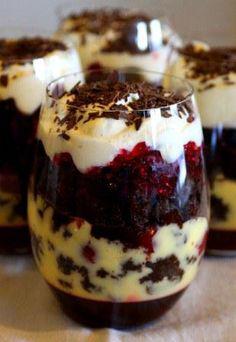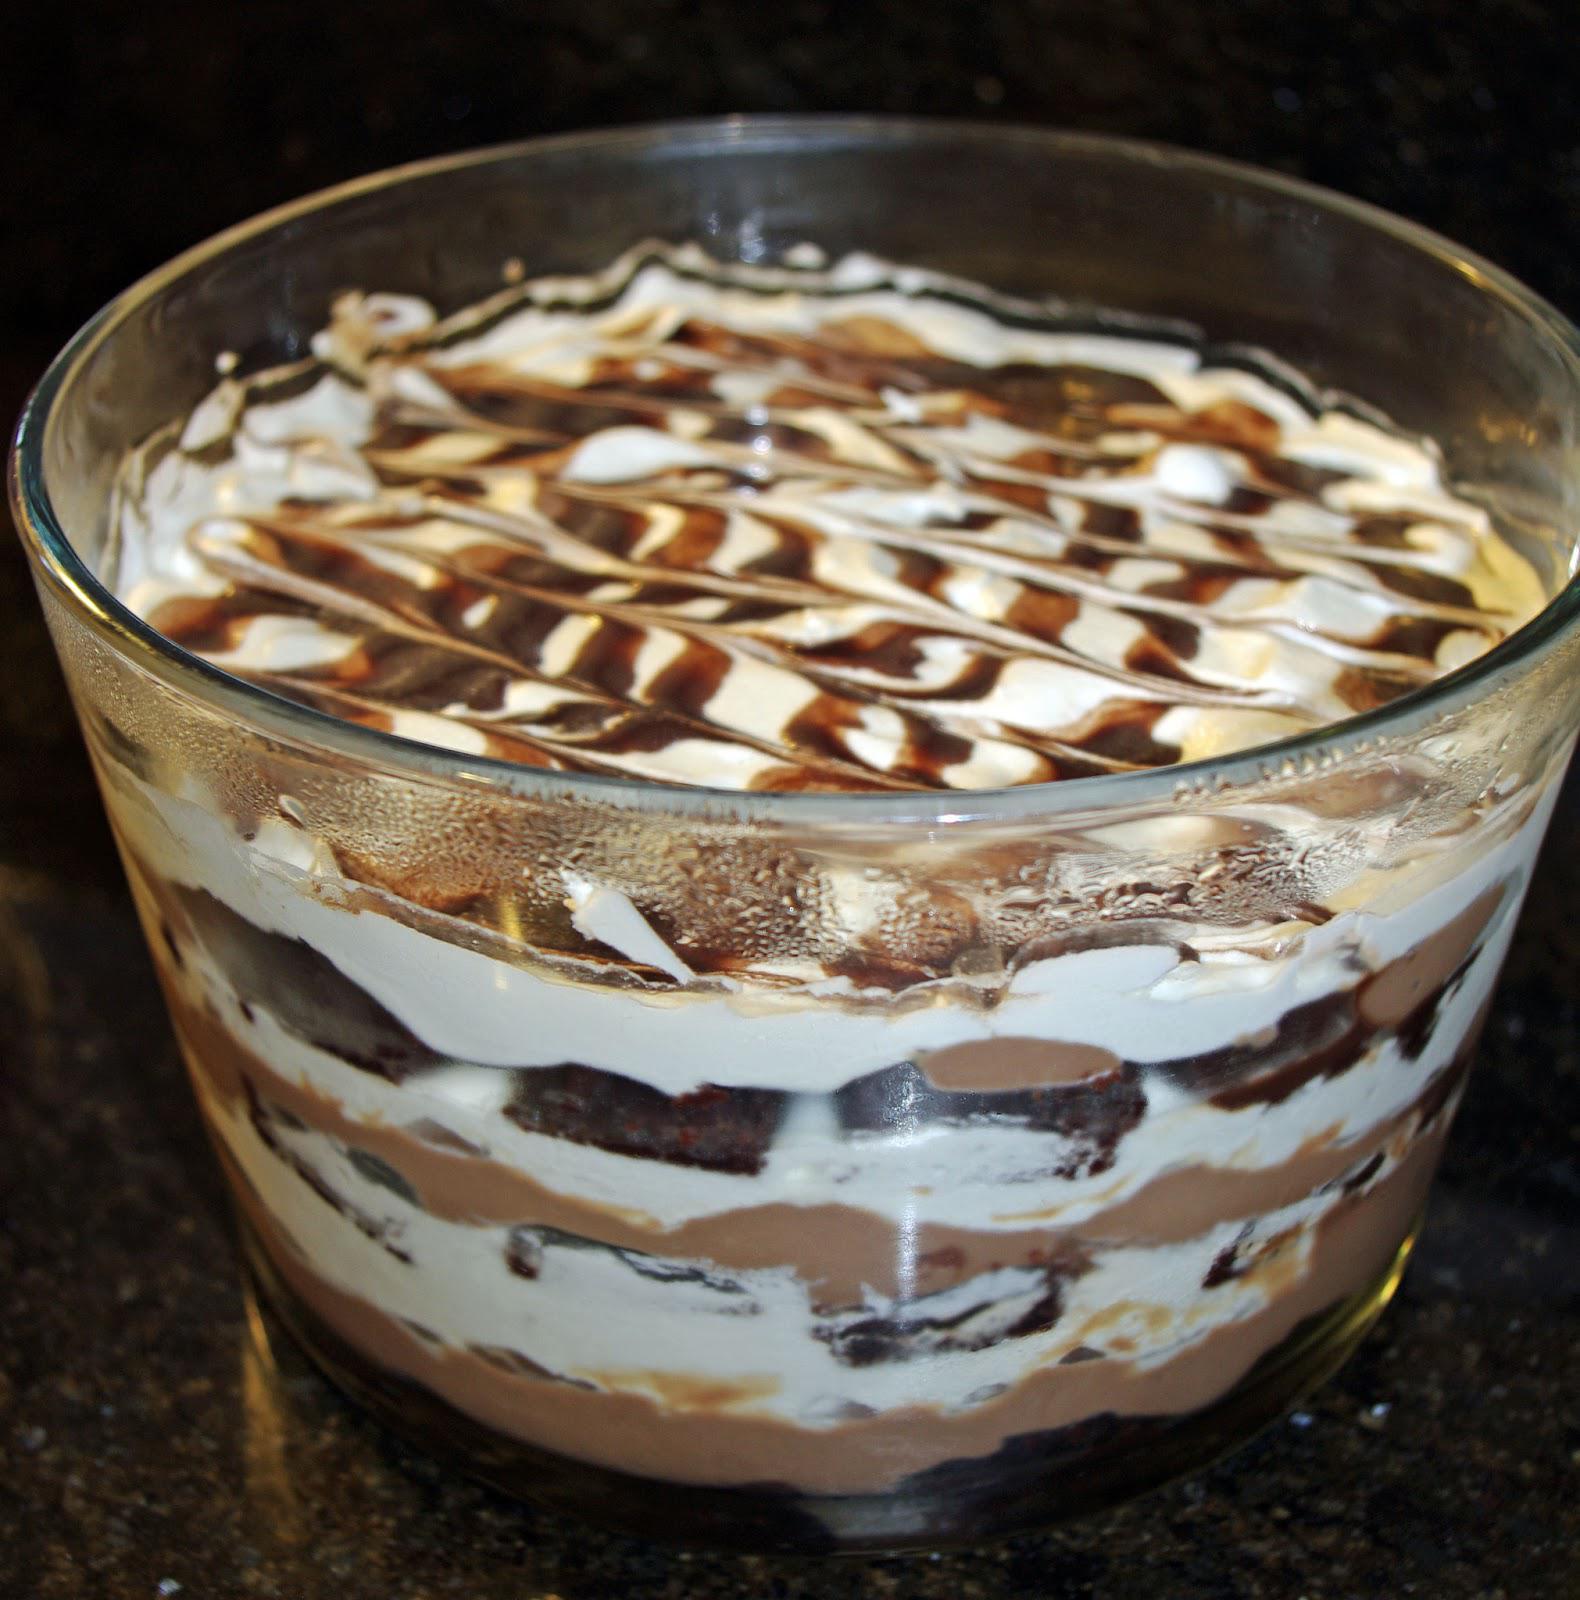The first image is the image on the left, the second image is the image on the right. Given the left and right images, does the statement "Each image shows at least three individual layered desserts, one at the front and others behind it, made in clear glasses with a garnished top." hold true? Answer yes or no. No. 